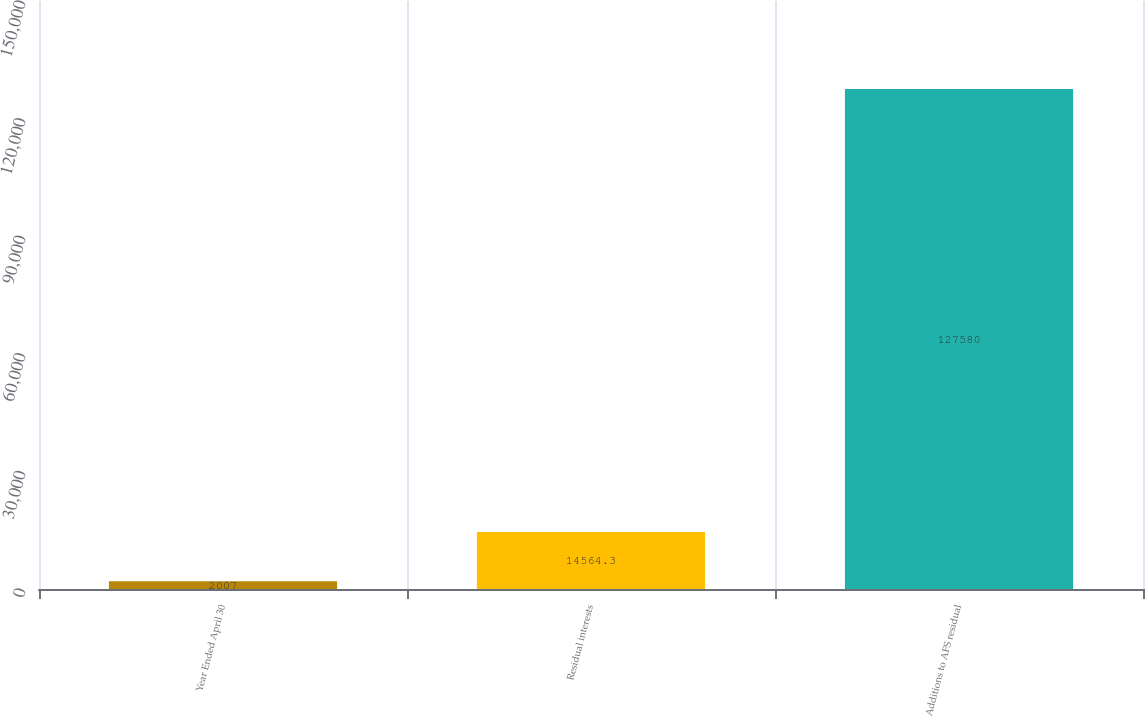Convert chart to OTSL. <chart><loc_0><loc_0><loc_500><loc_500><bar_chart><fcel>Year Ended April 30<fcel>Residual interests<fcel>Additions to AFS residual<nl><fcel>2007<fcel>14564.3<fcel>127580<nl></chart> 